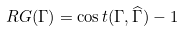<formula> <loc_0><loc_0><loc_500><loc_500>R G ( \Gamma ) = \cos t ( \Gamma , \widehat { \Gamma } ) - 1</formula> 